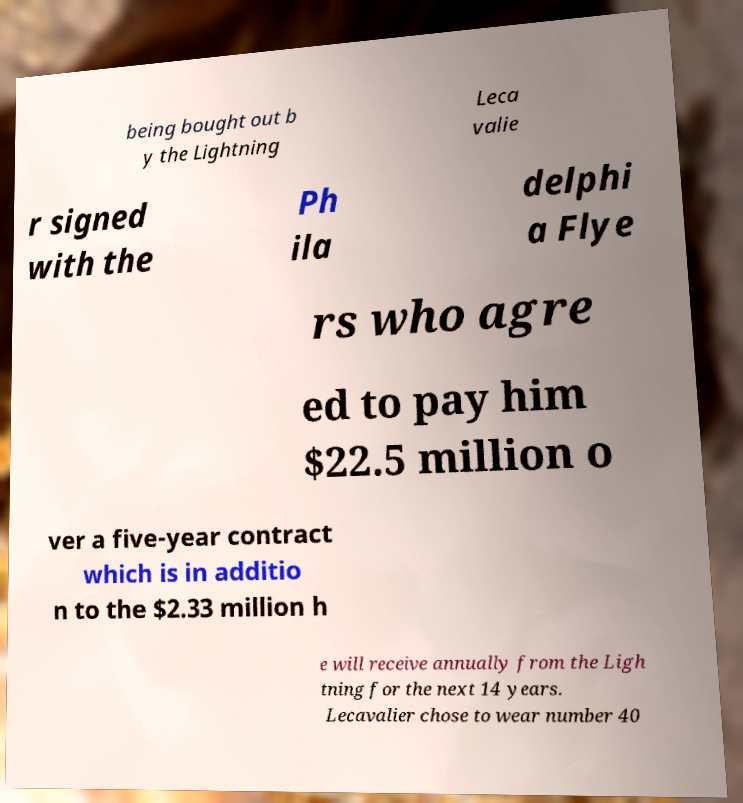Could you assist in decoding the text presented in this image and type it out clearly? being bought out b y the Lightning Leca valie r signed with the Ph ila delphi a Flye rs who agre ed to pay him $22.5 million o ver a five-year contract which is in additio n to the $2.33 million h e will receive annually from the Ligh tning for the next 14 years. Lecavalier chose to wear number 40 